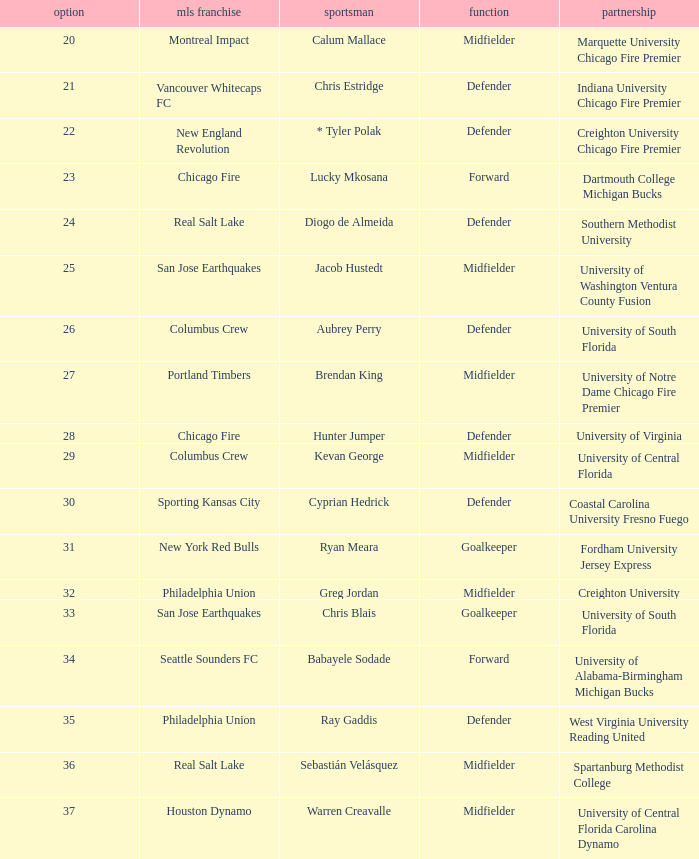Who was pick number 34? Babayele Sodade. 